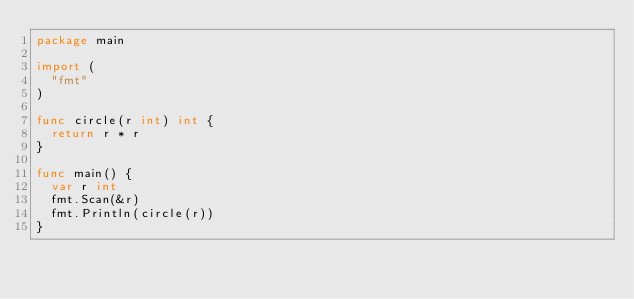<code> <loc_0><loc_0><loc_500><loc_500><_Go_>package main

import (
	"fmt"
)

func circle(r int) int {
	return r * r
}

func main() {
	var r int
	fmt.Scan(&r)
	fmt.Println(circle(r))
}
</code> 